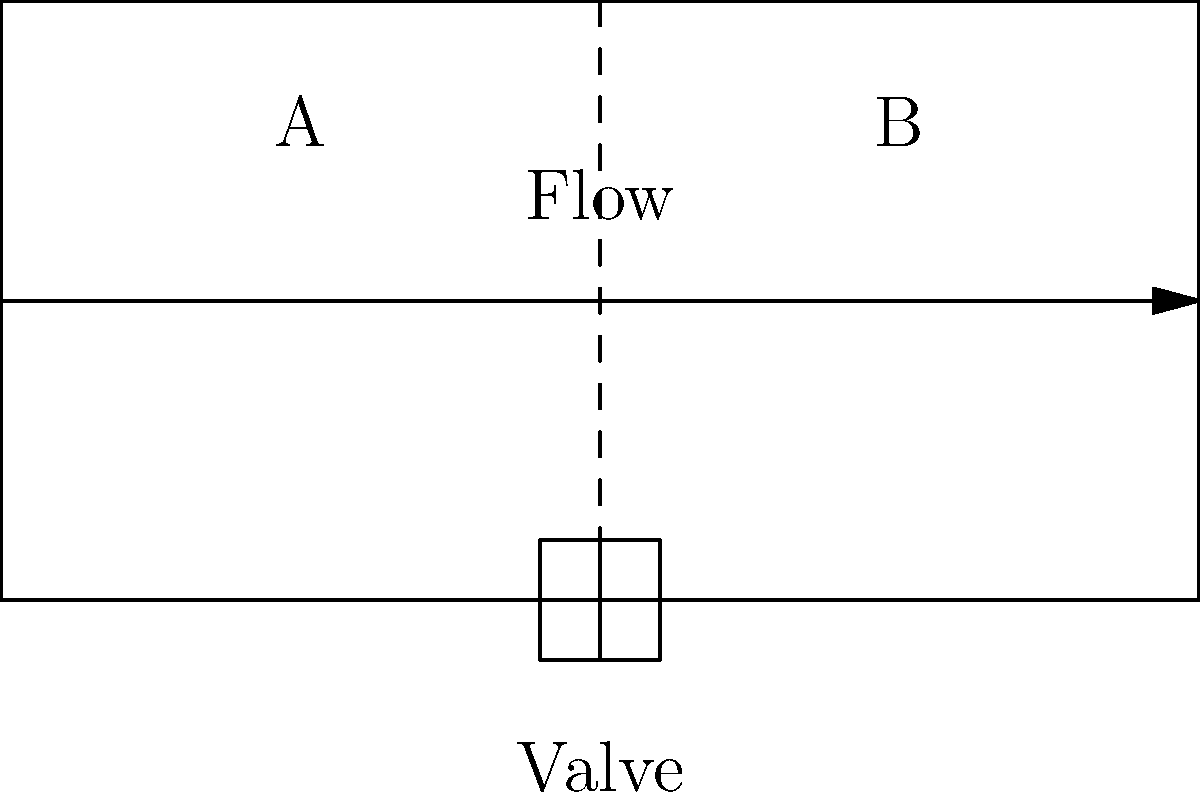In the irrigation system shown above, water flows from section A to section B through a valve. If the flow rate through the valve is 20 L/min and the cross-sectional area of section B is twice that of section A, what is the ratio of water velocity in section B compared to section A? To solve this problem, we'll use the principle of continuity in fluid dynamics. Here's a step-by-step explanation:

1. The principle of continuity states that for an incompressible fluid in a closed system, the volume flow rate is constant. This can be expressed as:

   $Q = A_1v_1 = A_2v_2$

   Where $Q$ is the flow rate, $A$ is the cross-sectional area, and $v$ is the velocity.

2. We're given that the flow rate is 20 L/min, which is constant throughout the system.

3. We're also told that the cross-sectional area of section B is twice that of section A:

   $A_B = 2A_A$

4. Let's denote the velocity in section A as $v_A$ and in section B as $v_B$.

5. Applying the continuity equation:

   $Q = A_Av_A = A_Bv_B$

6. Substituting $A_B = 2A_A$:

   $A_Av_A = 2A_Av_B$

7. Simplifying:

   $v_A = 2v_B$

8. To find the ratio of $v_B$ to $v_A$, we divide both sides by $v_A$:

   $\frac{v_B}{v_A} = \frac{1}{2}$

This means the velocity in section B is half of the velocity in section A.
Answer: $\frac{1}{2}$ 